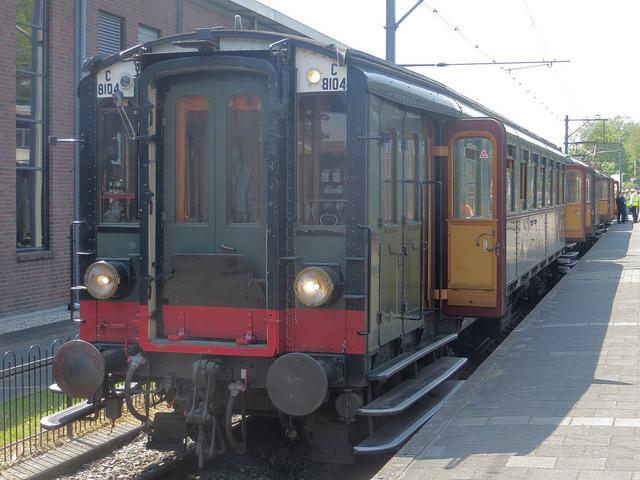How many Windows in the picture?
Keep it brief. 19. Is anyone standing near the train?
Give a very brief answer. Yes. How many doors are open?
Keep it brief. 5. What letter is on the front of the train?
Answer briefly. C. 